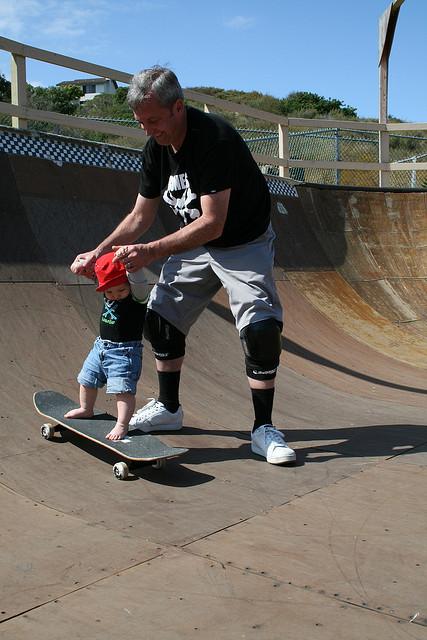Is the man skating?
Keep it brief. No. Is the person with the skateboard a child?
Write a very short answer. Yes. What color is the man's shirt?
Concise answer only. Black. Why is he wearing knee pads?
Keep it brief. Protection. Is the man wearing the same colored socks?
Give a very brief answer. Yes. What color is the child's cap?
Short answer required. Red. What color is the man's hair?
Concise answer only. Gray. What color are the skaters socks?
Answer briefly. Black. Would the skater increase his speed if he continued to kick his foot?
Write a very short answer. Yes. Why is his pants up so high?
Give a very brief answer. So they don't fall. Does this boy know how to skateboard?
Answer briefly. No. Is this man young or old?
Answer briefly. Old. What is the little kid riding?
Give a very brief answer. Skateboard. 